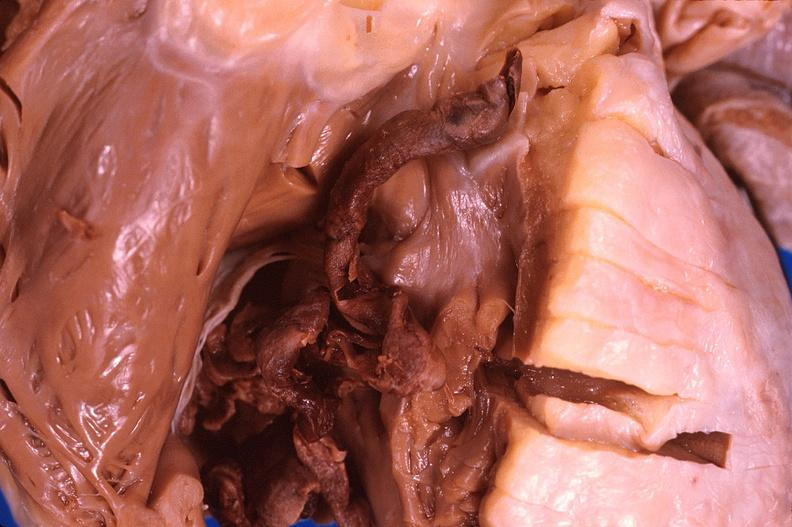what does this image show?
Answer the question using a single word or phrase. Thromboembolus from leg veins in right ventricle 